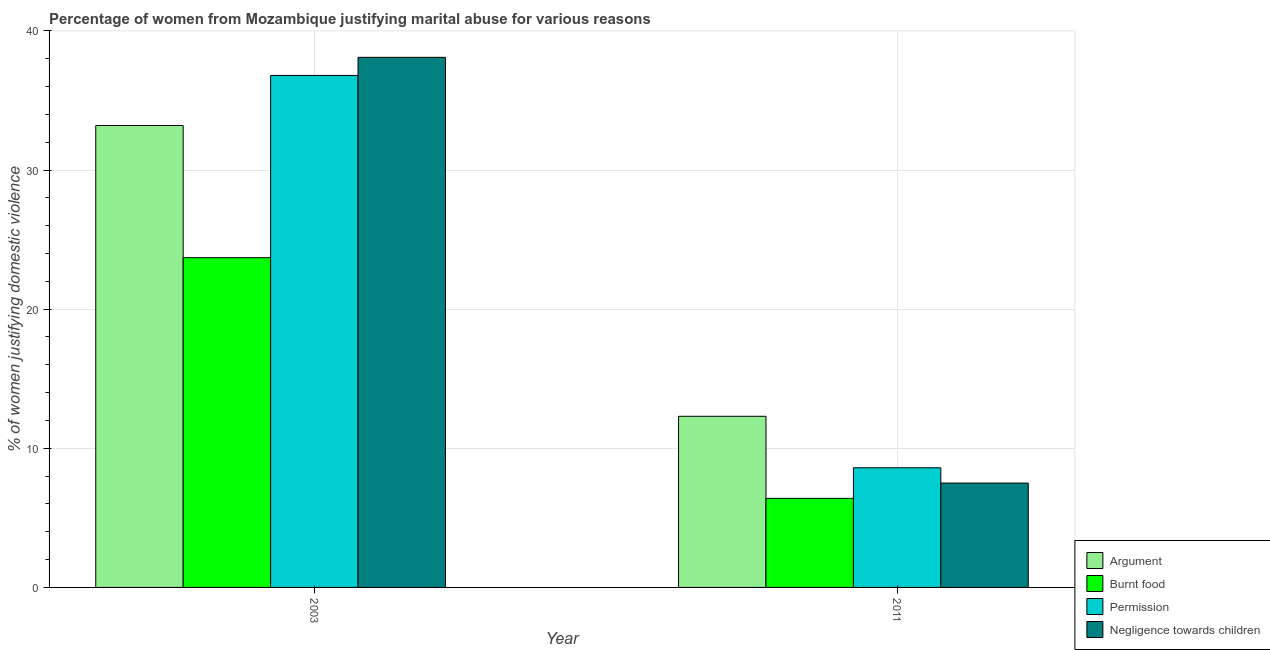How many groups of bars are there?
Ensure brevity in your answer.  2. What is the label of the 2nd group of bars from the left?
Provide a short and direct response. 2011. In how many cases, is the number of bars for a given year not equal to the number of legend labels?
Make the answer very short. 0. What is the percentage of women justifying abuse in the case of an argument in 2003?
Your answer should be very brief. 33.2. Across all years, what is the maximum percentage of women justifying abuse for going without permission?
Make the answer very short. 36.8. Across all years, what is the minimum percentage of women justifying abuse for going without permission?
Your answer should be very brief. 8.6. In which year was the percentage of women justifying abuse for burning food minimum?
Keep it short and to the point. 2011. What is the total percentage of women justifying abuse for burning food in the graph?
Provide a short and direct response. 30.1. What is the difference between the percentage of women justifying abuse for showing negligence towards children in 2003 and that in 2011?
Offer a terse response. 30.6. What is the difference between the percentage of women justifying abuse for going without permission in 2011 and the percentage of women justifying abuse for showing negligence towards children in 2003?
Your answer should be compact. -28.2. What is the average percentage of women justifying abuse for showing negligence towards children per year?
Offer a very short reply. 22.8. What is the ratio of the percentage of women justifying abuse for showing negligence towards children in 2003 to that in 2011?
Provide a succinct answer. 5.08. Is the percentage of women justifying abuse for showing negligence towards children in 2003 less than that in 2011?
Provide a succinct answer. No. In how many years, is the percentage of women justifying abuse for burning food greater than the average percentage of women justifying abuse for burning food taken over all years?
Offer a very short reply. 1. What does the 4th bar from the left in 2003 represents?
Give a very brief answer. Negligence towards children. What does the 3rd bar from the right in 2011 represents?
Keep it short and to the point. Burnt food. How many bars are there?
Your response must be concise. 8. How many years are there in the graph?
Your response must be concise. 2. Does the graph contain any zero values?
Your answer should be compact. No. Where does the legend appear in the graph?
Ensure brevity in your answer.  Bottom right. What is the title of the graph?
Keep it short and to the point. Percentage of women from Mozambique justifying marital abuse for various reasons. What is the label or title of the X-axis?
Make the answer very short. Year. What is the label or title of the Y-axis?
Offer a very short reply. % of women justifying domestic violence. What is the % of women justifying domestic violence in Argument in 2003?
Ensure brevity in your answer.  33.2. What is the % of women justifying domestic violence of Burnt food in 2003?
Your answer should be very brief. 23.7. What is the % of women justifying domestic violence in Permission in 2003?
Offer a terse response. 36.8. What is the % of women justifying domestic violence in Negligence towards children in 2003?
Your answer should be very brief. 38.1. What is the % of women justifying domestic violence of Argument in 2011?
Ensure brevity in your answer.  12.3. What is the % of women justifying domestic violence of Burnt food in 2011?
Keep it short and to the point. 6.4. What is the % of women justifying domestic violence in Permission in 2011?
Ensure brevity in your answer.  8.6. What is the % of women justifying domestic violence in Negligence towards children in 2011?
Provide a short and direct response. 7.5. Across all years, what is the maximum % of women justifying domestic violence in Argument?
Keep it short and to the point. 33.2. Across all years, what is the maximum % of women justifying domestic violence in Burnt food?
Your answer should be very brief. 23.7. Across all years, what is the maximum % of women justifying domestic violence of Permission?
Make the answer very short. 36.8. Across all years, what is the maximum % of women justifying domestic violence of Negligence towards children?
Your response must be concise. 38.1. Across all years, what is the minimum % of women justifying domestic violence in Burnt food?
Ensure brevity in your answer.  6.4. Across all years, what is the minimum % of women justifying domestic violence of Negligence towards children?
Make the answer very short. 7.5. What is the total % of women justifying domestic violence of Argument in the graph?
Your response must be concise. 45.5. What is the total % of women justifying domestic violence in Burnt food in the graph?
Your response must be concise. 30.1. What is the total % of women justifying domestic violence of Permission in the graph?
Keep it short and to the point. 45.4. What is the total % of women justifying domestic violence of Negligence towards children in the graph?
Your answer should be very brief. 45.6. What is the difference between the % of women justifying domestic violence in Argument in 2003 and that in 2011?
Your answer should be very brief. 20.9. What is the difference between the % of women justifying domestic violence in Burnt food in 2003 and that in 2011?
Offer a terse response. 17.3. What is the difference between the % of women justifying domestic violence in Permission in 2003 and that in 2011?
Make the answer very short. 28.2. What is the difference between the % of women justifying domestic violence of Negligence towards children in 2003 and that in 2011?
Keep it short and to the point. 30.6. What is the difference between the % of women justifying domestic violence in Argument in 2003 and the % of women justifying domestic violence in Burnt food in 2011?
Provide a short and direct response. 26.8. What is the difference between the % of women justifying domestic violence of Argument in 2003 and the % of women justifying domestic violence of Permission in 2011?
Your response must be concise. 24.6. What is the difference between the % of women justifying domestic violence of Argument in 2003 and the % of women justifying domestic violence of Negligence towards children in 2011?
Keep it short and to the point. 25.7. What is the difference between the % of women justifying domestic violence of Burnt food in 2003 and the % of women justifying domestic violence of Negligence towards children in 2011?
Your answer should be very brief. 16.2. What is the difference between the % of women justifying domestic violence of Permission in 2003 and the % of women justifying domestic violence of Negligence towards children in 2011?
Your answer should be compact. 29.3. What is the average % of women justifying domestic violence in Argument per year?
Give a very brief answer. 22.75. What is the average % of women justifying domestic violence in Burnt food per year?
Your answer should be very brief. 15.05. What is the average % of women justifying domestic violence of Permission per year?
Keep it short and to the point. 22.7. What is the average % of women justifying domestic violence in Negligence towards children per year?
Offer a terse response. 22.8. In the year 2003, what is the difference between the % of women justifying domestic violence of Argument and % of women justifying domestic violence of Burnt food?
Your answer should be very brief. 9.5. In the year 2003, what is the difference between the % of women justifying domestic violence in Burnt food and % of women justifying domestic violence in Permission?
Provide a short and direct response. -13.1. In the year 2003, what is the difference between the % of women justifying domestic violence in Burnt food and % of women justifying domestic violence in Negligence towards children?
Provide a short and direct response. -14.4. In the year 2003, what is the difference between the % of women justifying domestic violence in Permission and % of women justifying domestic violence in Negligence towards children?
Provide a succinct answer. -1.3. In the year 2011, what is the difference between the % of women justifying domestic violence in Argument and % of women justifying domestic violence in Burnt food?
Make the answer very short. 5.9. In the year 2011, what is the difference between the % of women justifying domestic violence of Argument and % of women justifying domestic violence of Permission?
Keep it short and to the point. 3.7. In the year 2011, what is the difference between the % of women justifying domestic violence of Burnt food and % of women justifying domestic violence of Permission?
Your response must be concise. -2.2. What is the ratio of the % of women justifying domestic violence in Argument in 2003 to that in 2011?
Provide a short and direct response. 2.7. What is the ratio of the % of women justifying domestic violence in Burnt food in 2003 to that in 2011?
Your answer should be compact. 3.7. What is the ratio of the % of women justifying domestic violence of Permission in 2003 to that in 2011?
Offer a very short reply. 4.28. What is the ratio of the % of women justifying domestic violence of Negligence towards children in 2003 to that in 2011?
Your answer should be very brief. 5.08. What is the difference between the highest and the second highest % of women justifying domestic violence in Argument?
Provide a short and direct response. 20.9. What is the difference between the highest and the second highest % of women justifying domestic violence of Permission?
Offer a very short reply. 28.2. What is the difference between the highest and the second highest % of women justifying domestic violence in Negligence towards children?
Make the answer very short. 30.6. What is the difference between the highest and the lowest % of women justifying domestic violence in Argument?
Provide a short and direct response. 20.9. What is the difference between the highest and the lowest % of women justifying domestic violence of Permission?
Keep it short and to the point. 28.2. What is the difference between the highest and the lowest % of women justifying domestic violence of Negligence towards children?
Your response must be concise. 30.6. 